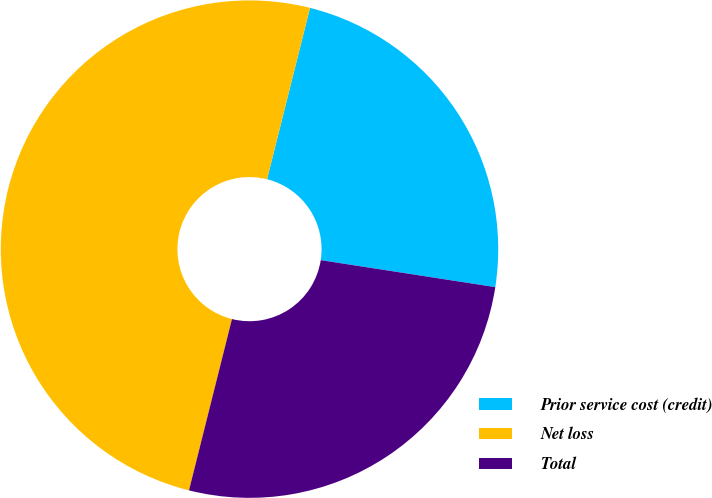Convert chart. <chart><loc_0><loc_0><loc_500><loc_500><pie_chart><fcel>Prior service cost (credit)<fcel>Net loss<fcel>Total<nl><fcel>23.53%<fcel>50.0%<fcel>26.47%<nl></chart> 